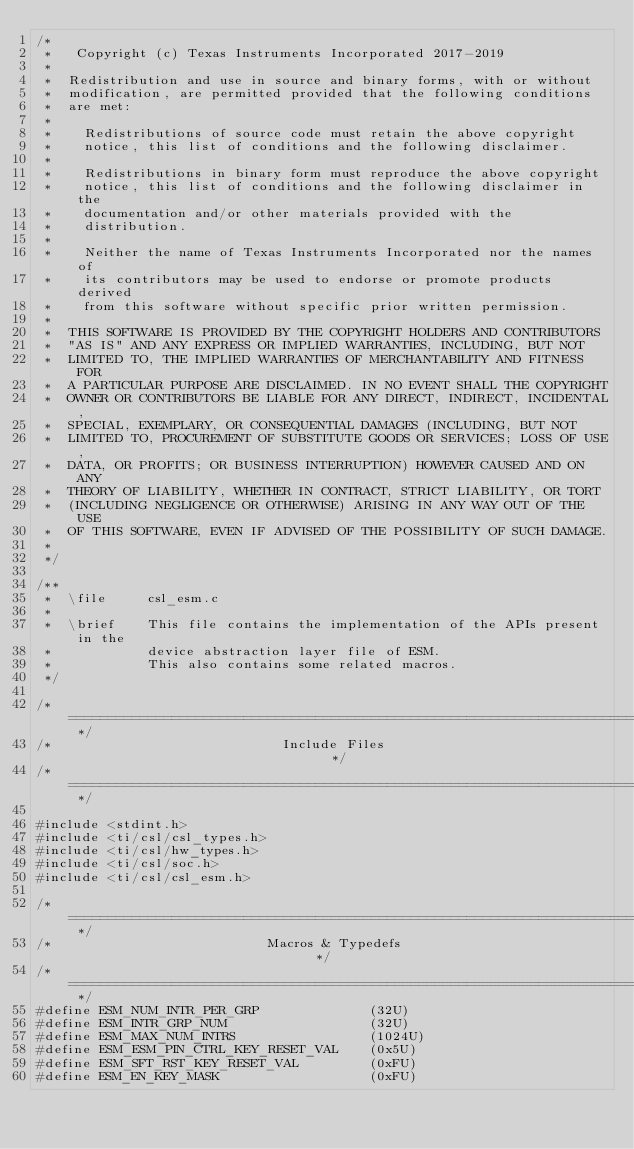Convert code to text. <code><loc_0><loc_0><loc_500><loc_500><_C_>/*
 *   Copyright (c) Texas Instruments Incorporated 2017-2019
 *
 *  Redistribution and use in source and binary forms, with or without
 *  modification, are permitted provided that the following conditions
 *  are met:
 *
 *    Redistributions of source code must retain the above copyright
 *    notice, this list of conditions and the following disclaimer.
 *
 *    Redistributions in binary form must reproduce the above copyright
 *    notice, this list of conditions and the following disclaimer in the
 *    documentation and/or other materials provided with the
 *    distribution.
 *
 *    Neither the name of Texas Instruments Incorporated nor the names of
 *    its contributors may be used to endorse or promote products derived
 *    from this software without specific prior written permission.
 *
 *  THIS SOFTWARE IS PROVIDED BY THE COPYRIGHT HOLDERS AND CONTRIBUTORS
 *  "AS IS" AND ANY EXPRESS OR IMPLIED WARRANTIES, INCLUDING, BUT NOT
 *  LIMITED TO, THE IMPLIED WARRANTIES OF MERCHANTABILITY AND FITNESS FOR
 *  A PARTICULAR PURPOSE ARE DISCLAIMED. IN NO EVENT SHALL THE COPYRIGHT
 *  OWNER OR CONTRIBUTORS BE LIABLE FOR ANY DIRECT, INDIRECT, INCIDENTAL,
 *  SPECIAL, EXEMPLARY, OR CONSEQUENTIAL DAMAGES (INCLUDING, BUT NOT
 *  LIMITED TO, PROCUREMENT OF SUBSTITUTE GOODS OR SERVICES; LOSS OF USE,
 *  DATA, OR PROFITS; OR BUSINESS INTERRUPTION) HOWEVER CAUSED AND ON ANY
 *  THEORY OF LIABILITY, WHETHER IN CONTRACT, STRICT LIABILITY, OR TORT
 *  (INCLUDING NEGLIGENCE OR OTHERWISE) ARISING IN ANY WAY OUT OF THE USE
 *  OF THIS SOFTWARE, EVEN IF ADVISED OF THE POSSIBILITY OF SUCH DAMAGE.
 *
 */

/**
 *  \file     csl_esm.c
 *
 *  \brief    This file contains the implementation of the APIs present in the
 *            device abstraction layer file of ESM.
 *            This also contains some related macros.
 */

/* ========================================================================== */
/*                             Include Files                                  */
/* ========================================================================== */

#include <stdint.h>
#include <ti/csl/csl_types.h>
#include <ti/csl/hw_types.h>
#include <ti/csl/soc.h>
#include <ti/csl/csl_esm.h>

/* ========================================================================== */
/*                           Macros & Typedefs                                */
/* ========================================================================== */
#define ESM_NUM_INTR_PER_GRP              (32U)
#define ESM_INTR_GRP_NUM                  (32U)
#define ESM_MAX_NUM_INTRS                 (1024U)
#define ESM_ESM_PIN_CTRL_KEY_RESET_VAL    (0x5U)
#define ESM_SFT_RST_KEY_RESET_VAL         (0xFU)
#define ESM_EN_KEY_MASK                   (0xFU)</code> 